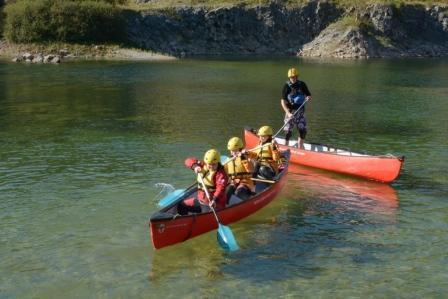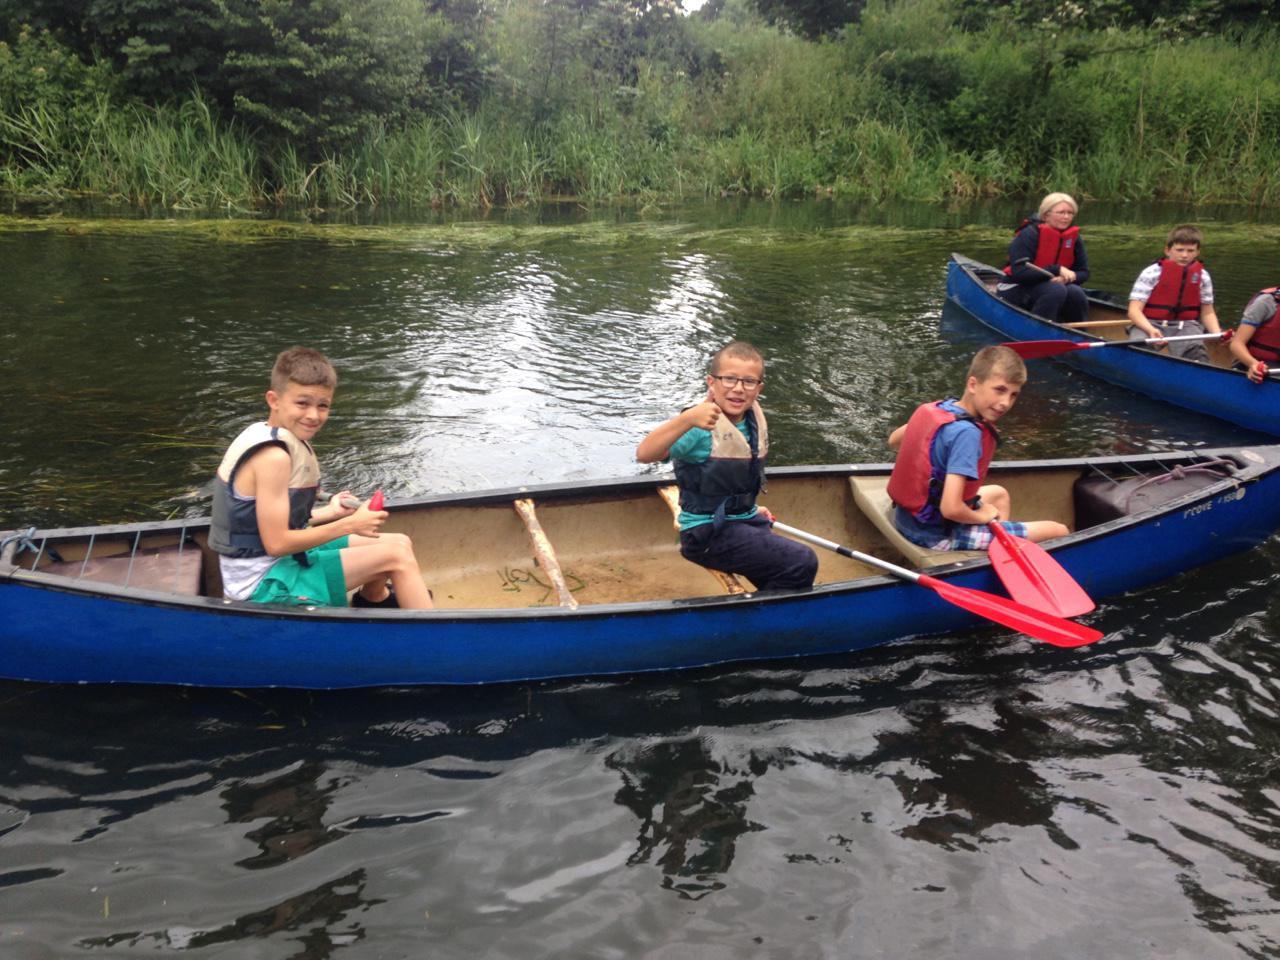The first image is the image on the left, the second image is the image on the right. Considering the images on both sides, is "The left and right image contains a total of four boats." valid? Answer yes or no. Yes. The first image is the image on the left, the second image is the image on the right. Given the left and right images, does the statement "An image includes a red canoe with three riders and no other canoe with a seated person in it." hold true? Answer yes or no. Yes. 